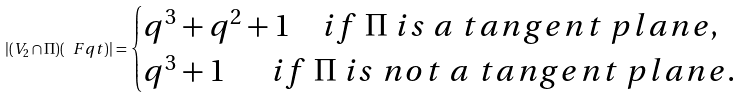<formula> <loc_0><loc_0><loc_500><loc_500>| ( V _ { 2 } \cap \Pi ) ( \ F q t ) | = \begin{cases} q ^ { 3 } + q ^ { 2 } + 1 \quad i f \ \Pi \ i s \ a \ t a n g e n t \ p l a n e , \\ q ^ { 3 } + 1 \quad \ \ i f \ \Pi \ i s \ n o t \ a \ t a n g e n t \ p l a n e . \end{cases}</formula> 